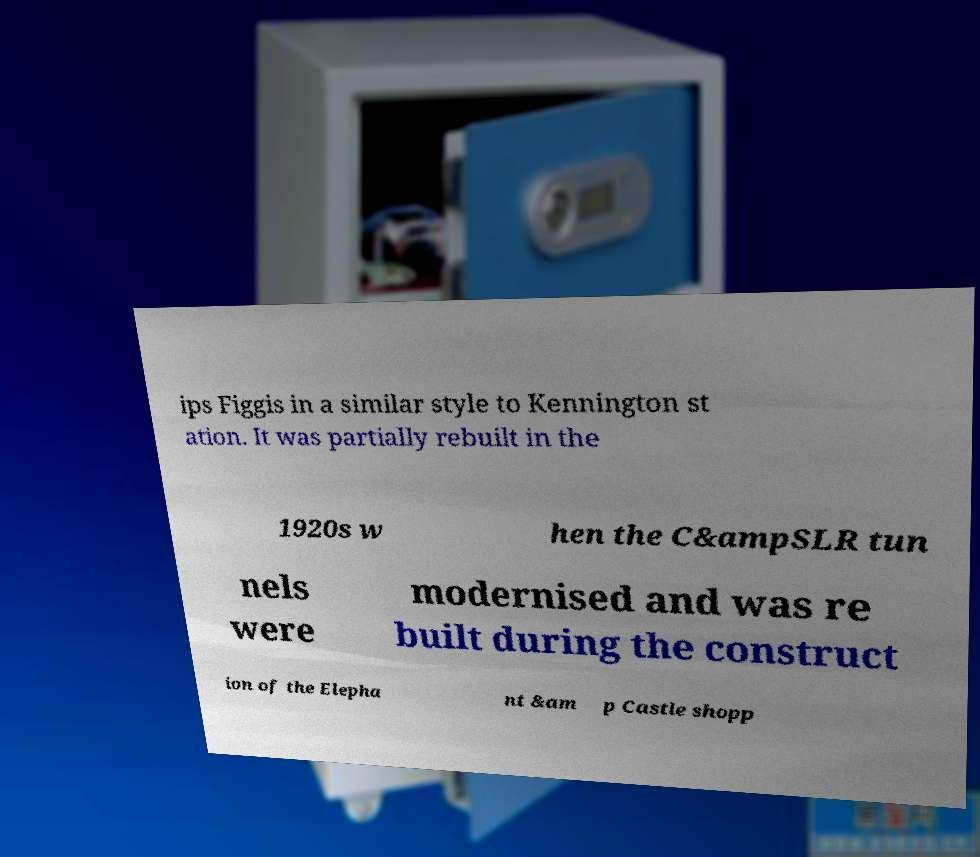Please identify and transcribe the text found in this image. ips Figgis in a similar style to Kennington st ation. It was partially rebuilt in the 1920s w hen the C&ampSLR tun nels were modernised and was re built during the construct ion of the Elepha nt &am p Castle shopp 